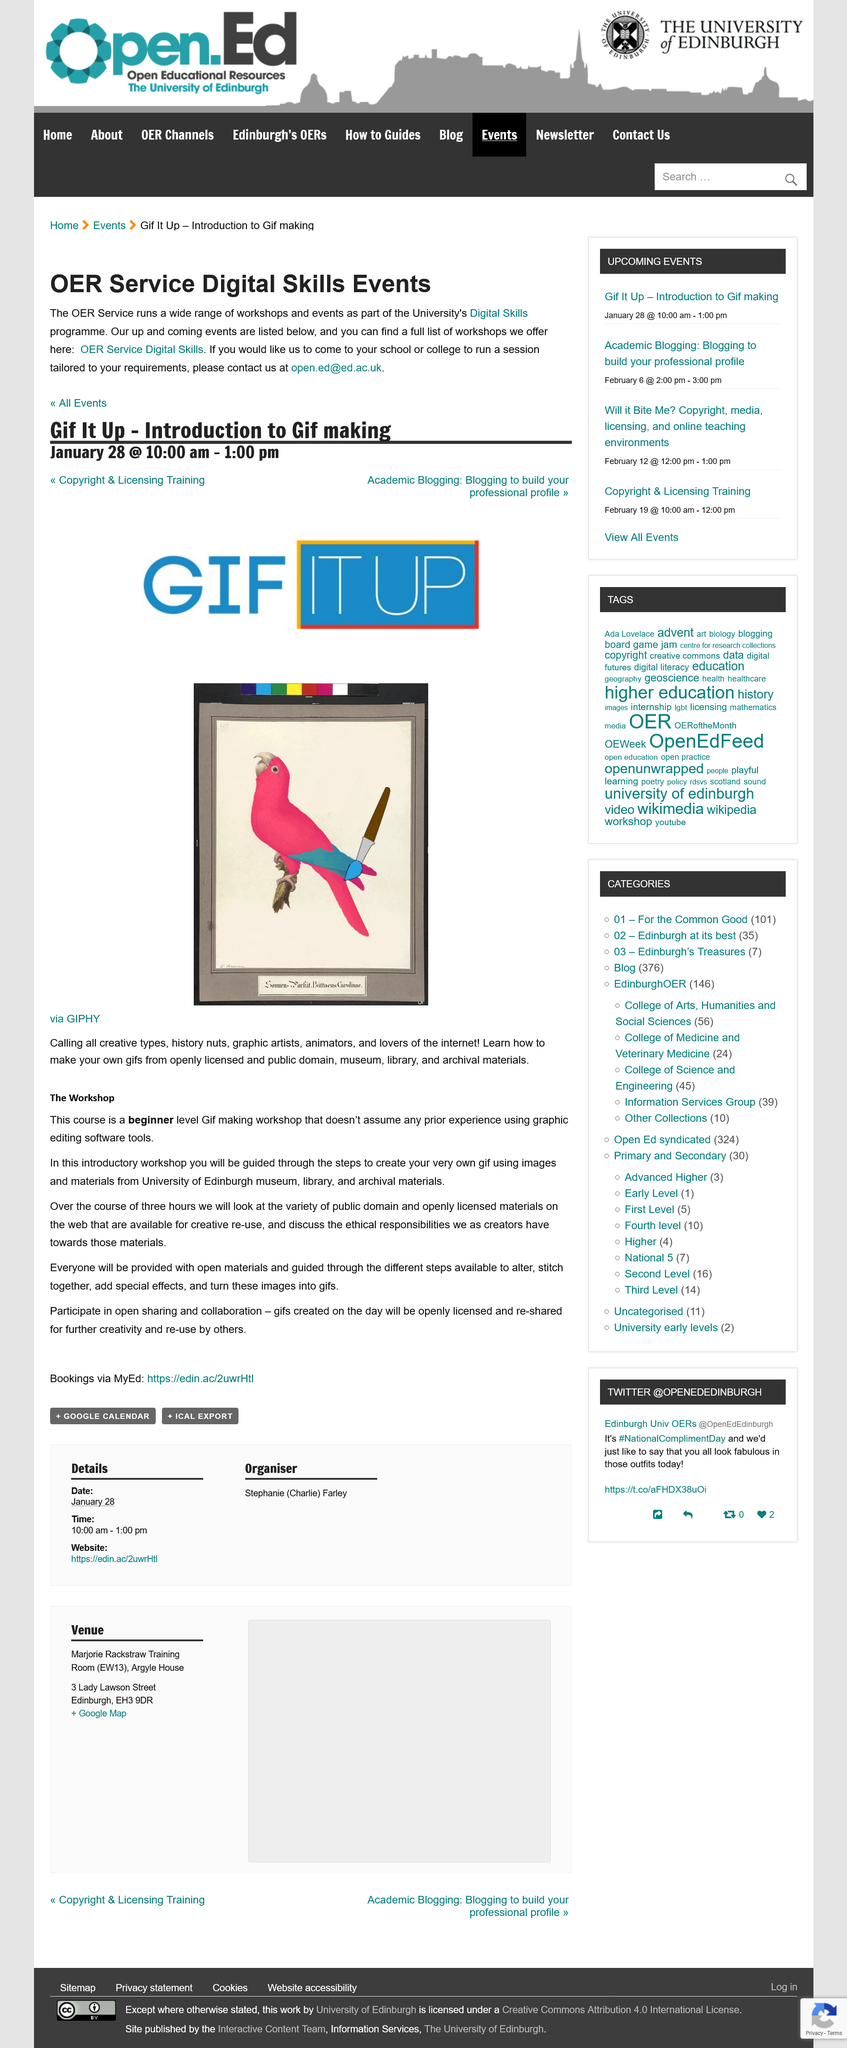Specify some key components in this picture. The workshop does not require any prior experience. The workshop is scheduled to last for a duration of 3 hours. The workshop course is designated for beginners. 